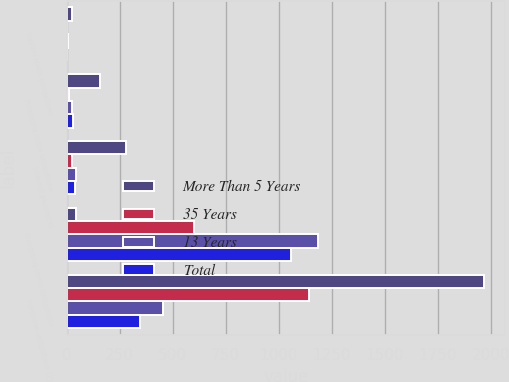<chart> <loc_0><loc_0><loc_500><loc_500><stacked_bar_chart><ecel><fcel>Capital lease obligations<fcel>Financing lease obligations<fcel>Interest payments<fcel>Operating lease obligations<fcel>Purchase obligations (2)<nl><fcel>More Than 5 Years<fcel>27<fcel>157<fcel>280<fcel>46<fcel>1968<nl><fcel>35 Years<fcel>3<fcel>12<fcel>24<fcel>602<fcel>1141<nl><fcel>13 Years<fcel>6<fcel>26<fcel>46<fcel>1187<fcel>454<nl><fcel>Total<fcel>4<fcel>29<fcel>41<fcel>1059<fcel>347<nl></chart> 